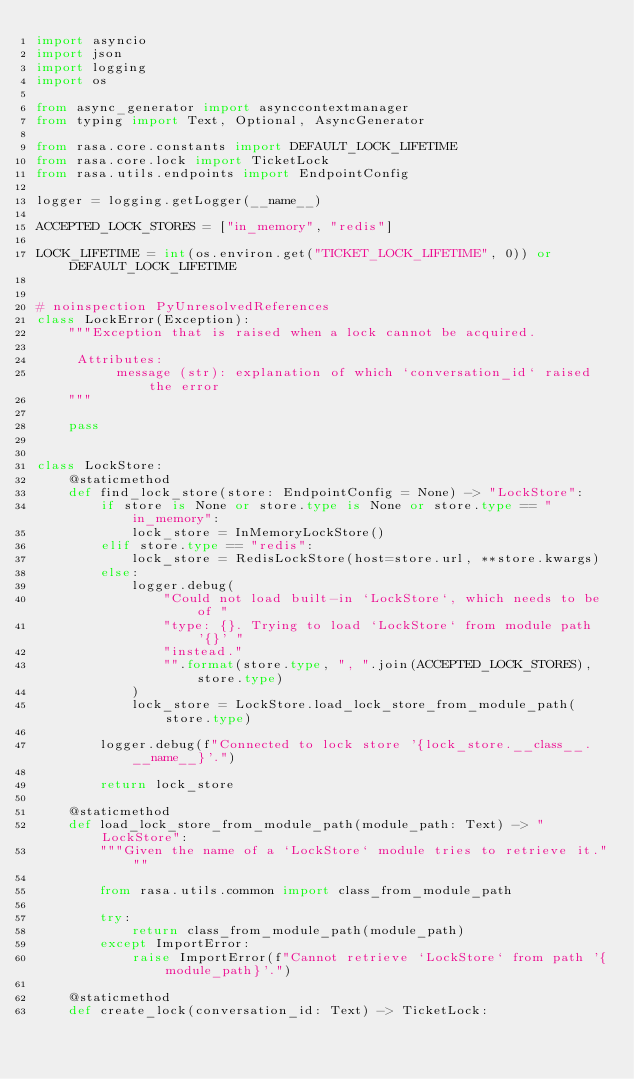Convert code to text. <code><loc_0><loc_0><loc_500><loc_500><_Python_>import asyncio
import json
import logging
import os

from async_generator import asynccontextmanager
from typing import Text, Optional, AsyncGenerator

from rasa.core.constants import DEFAULT_LOCK_LIFETIME
from rasa.core.lock import TicketLock
from rasa.utils.endpoints import EndpointConfig

logger = logging.getLogger(__name__)

ACCEPTED_LOCK_STORES = ["in_memory", "redis"]

LOCK_LIFETIME = int(os.environ.get("TICKET_LOCK_LIFETIME", 0)) or DEFAULT_LOCK_LIFETIME


# noinspection PyUnresolvedReferences
class LockError(Exception):
    """Exception that is raised when a lock cannot be acquired.

     Attributes:
          message (str): explanation of which `conversation_id` raised the error
    """

    pass


class LockStore:
    @staticmethod
    def find_lock_store(store: EndpointConfig = None) -> "LockStore":
        if store is None or store.type is None or store.type == "in_memory":
            lock_store = InMemoryLockStore()
        elif store.type == "redis":
            lock_store = RedisLockStore(host=store.url, **store.kwargs)
        else:
            logger.debug(
                "Could not load built-in `LockStore`, which needs to be of "
                "type: {}. Trying to load `LockStore` from module path '{}' "
                "instead."
                "".format(store.type, ", ".join(ACCEPTED_LOCK_STORES), store.type)
            )
            lock_store = LockStore.load_lock_store_from_module_path(store.type)

        logger.debug(f"Connected to lock store '{lock_store.__class__.__name__}'.")

        return lock_store

    @staticmethod
    def load_lock_store_from_module_path(module_path: Text) -> "LockStore":
        """Given the name of a `LockStore` module tries to retrieve it."""

        from rasa.utils.common import class_from_module_path

        try:
            return class_from_module_path(module_path)
        except ImportError:
            raise ImportError(f"Cannot retrieve `LockStore` from path '{module_path}'.")

    @staticmethod
    def create_lock(conversation_id: Text) -> TicketLock:</code> 